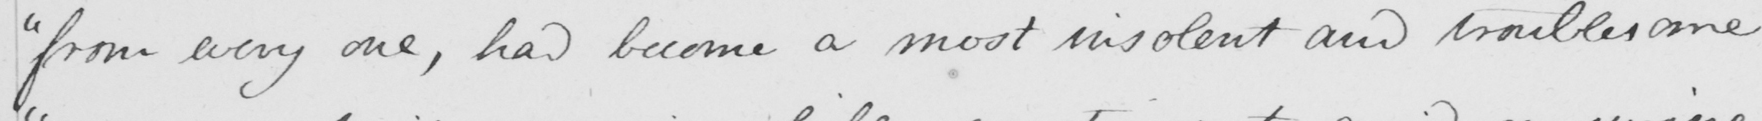What text is written in this handwritten line? " from every one , has become a most insolent and troublesome 